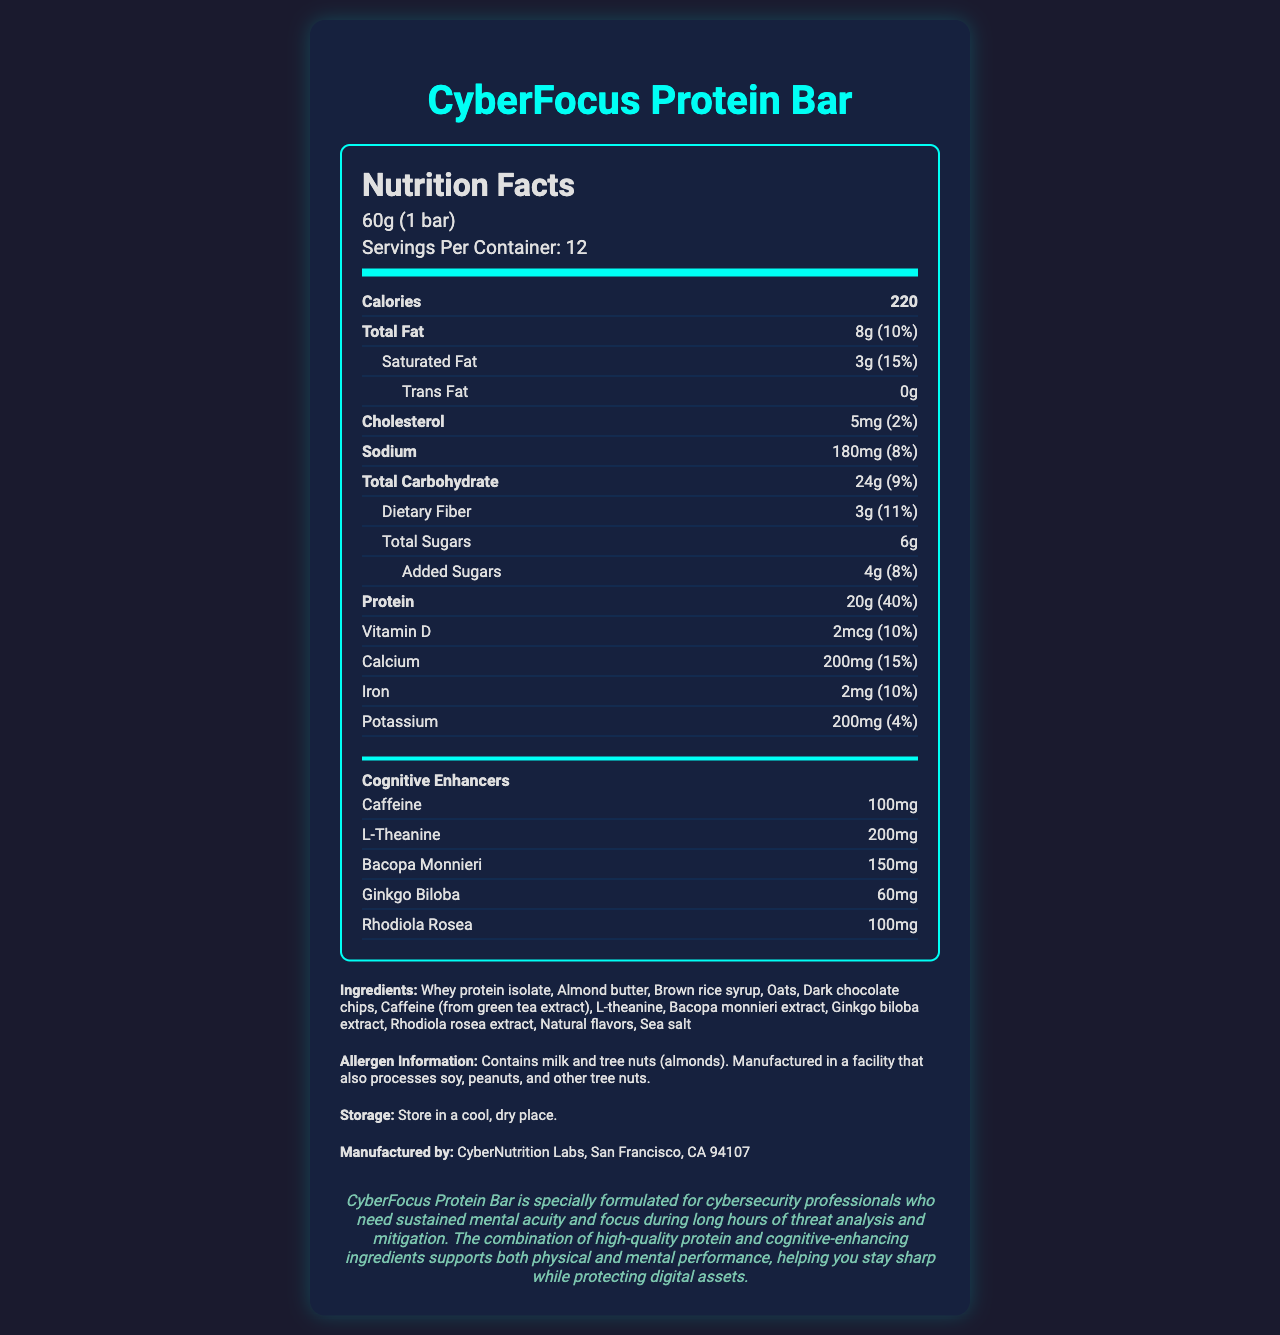what is the serving size of the CyberFocus Protein Bar? The serving size information is clearly stated as "60g (1 bar)" in the document.
Answer: 60g (1 bar) how many servings are in one container of the CyberFocus Protein Bar? The document states "Servings Per Container: 12".
Answer: 12 how much protein is in one serving of the CyberFocus Protein Bar? The amount of protein per serving is listed as "20g".
Answer: 20g what are the total calories in one serving? The total calories per serving is clearly indicated as "220".
Answer: 220 calories what cognitive-enhancing ingredients are included in the CyberFocus Protein Bar? The document lists these ingredients under the "Cognitive Enhancers" section.
Answer: Caffeine, L-theanine, Bacopa monnieri, Ginkgo biloba, Rhodiola rosea which of the following is not an ingredient in the CyberFocus Protein Bar? A. Dark chocolate chips B. Almond butter C. Soy protein D. Rhodiola rosea extract The ingredient list does not include soy protein, but it does include dark chocolate chips, almond butter, and Rhodiola rosea extract.
Answer: C. Soy protein what is the daily value percentage for calcium in the CyberFocus Protein Bar? The daily value percentage for calcium is listed as "15%".
Answer: 15% Is there any trans fat in the CyberFocus Protein Bar? The document states "Trans Fat: 0g".
Answer: No how should the CyberFocus Protein Bar be stored? The storage instructions state to "Store in a cool, dry place".
Answer: Store in a cool, dry place what is the primary audience or intended user of the CyberFocus Protein Bar according to the product description? The product description specifies that the bar is formulated for "cybersecurity professionals who need sustained mental acuity and focus".
Answer: Cybersecurity professionals what company manufactures the CyberFocus Protein Bar? The manufacturer information lists "CyberNutrition Labs, San Francisco, CA 94107".
Answer: CyberNutrition Labs, San Francisco, CA 94107 what is the daily value percentage of saturated fat in the CyberFocus Protein Bar? The daily value percentage for saturated fat is listed as "15%".
Answer: 15% how many grams of dietary fiber are in one serving? The document lists "Dietary Fiber: 3g".
Answer: 3g which of the following cognitive-enhancing ingredients is in the highest amount per serving? A. Caffeine B. Bacopa monnieri C. Ginkgo biloba D. L-theanine L-theanine has 200mg per serving, whereas caffeine has 100mg, Bacopa monnieri has 150mg, and Ginkgo biloba has 60mg.
Answer: D. L-theanine is the CyberFocus Protein Bar suitable for someone with a peanut allergy? The allergen information states that it is manufactured in a facility that processes peanuts.
Answer: No provide a summary of the CyberFocus Protein Bar's nutritional information and purpose. This summary captures the main nutritional details and purpose as described in the document, focusing on the intended benefits for cybersecurity professionals.
Answer: The CyberFocus Protein Bar contains 220 calories per serving with 8g of total fat, 20g of protein, and various cognitive-enhancing ingredients like caffeine and L-theanine. It's designed for cybersecurity professionals to support mental acuity and focus. what is the percentage of the daily value of sodium in one serving of the CyberFocus Protein Bar? The document states that the sodium in one serving is 180mg, which is 8% of the daily value.
Answer: 8% where is the CyberFocus Protein Bar manufactured? The manufacturer information specifies that it's made by CyberNutrition Labs in San Francisco, CA 94107.
Answer: San Francisco, CA 94107 how much Rhodiola rosea is included in one serving of the CyberFocus Protein Bar? The cognitive enhancers section lists 100mg of Rhodiola rosea per serving.
Answer: 100mg what is the total amount of sugars in one serving of the CyberFocus Protein Bar? The total sugars per serving is listed as 6g.
Answer: 6g what are the allergens mentioned in the CyberFocus Protein Bar? The document states that the bar contains milk and tree nuts (almonds).
Answer: Milk and tree nuts (almonds) what is the main fat source in the CyberFocus Protein Bar? The ingredients list includes almond butter, which is a primary source of fat.
Answer: Almond butter what is the percentage of the daily value for protein in the CyberFocus Protein Bar? The document states that the protein content provides 40% of the daily value.
Answer: 40% how many grams of total carbohydrates are in one serving? The total carbohydrate content per serving is listed as 24g.
Answer: 24g does the CyberFocus Protein Bar contain any iron? If so, how much? The document lists the iron content as 2mg, which is 10% of the daily value.
Answer: Yes, 2mg what is the purpose of including L-theanine in the CyberFocus Protein Bar? According to the document, L-theanine is included for its cognitive-enhancing properties.
Answer: To enhance cognitive performance 